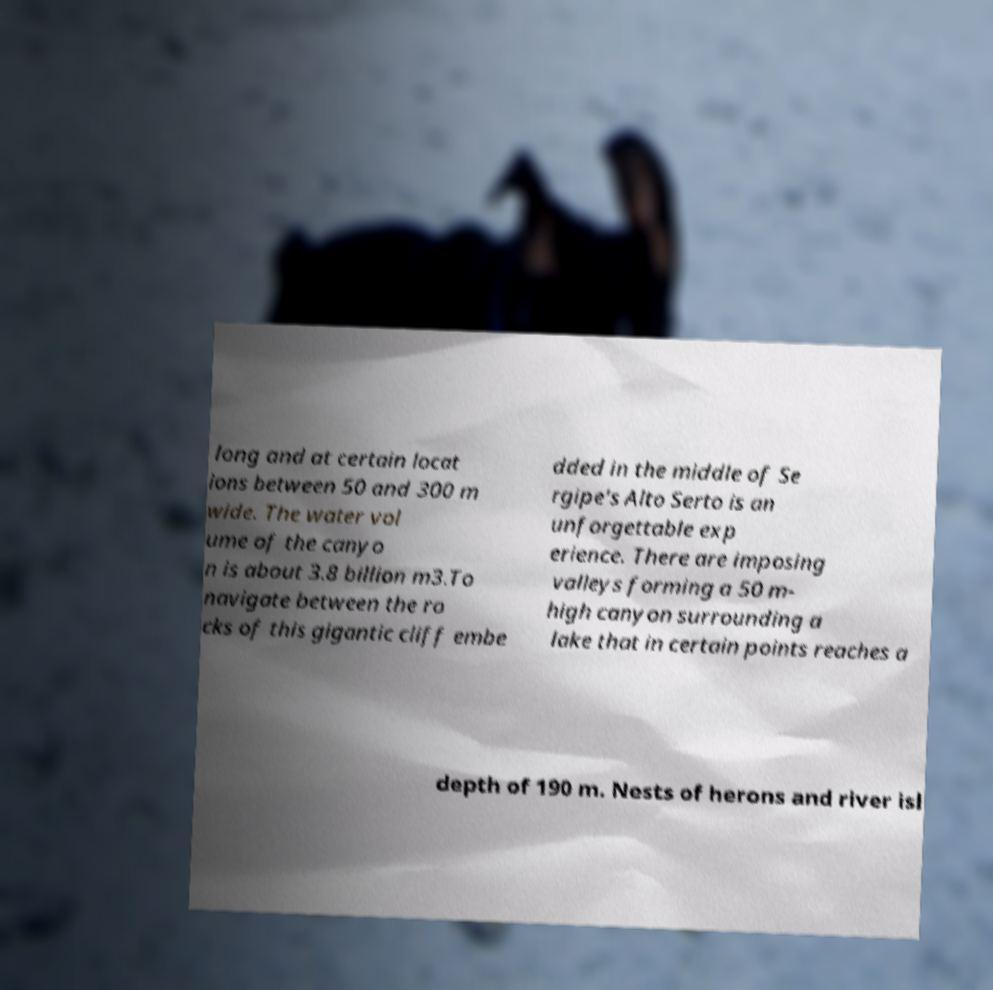For documentation purposes, I need the text within this image transcribed. Could you provide that? long and at certain locat ions between 50 and 300 m wide. The water vol ume of the canyo n is about 3.8 billion m3.To navigate between the ro cks of this gigantic cliff embe dded in the middle of Se rgipe's Alto Serto is an unforgettable exp erience. There are imposing valleys forming a 50 m- high canyon surrounding a lake that in certain points reaches a depth of 190 m. Nests of herons and river isl 